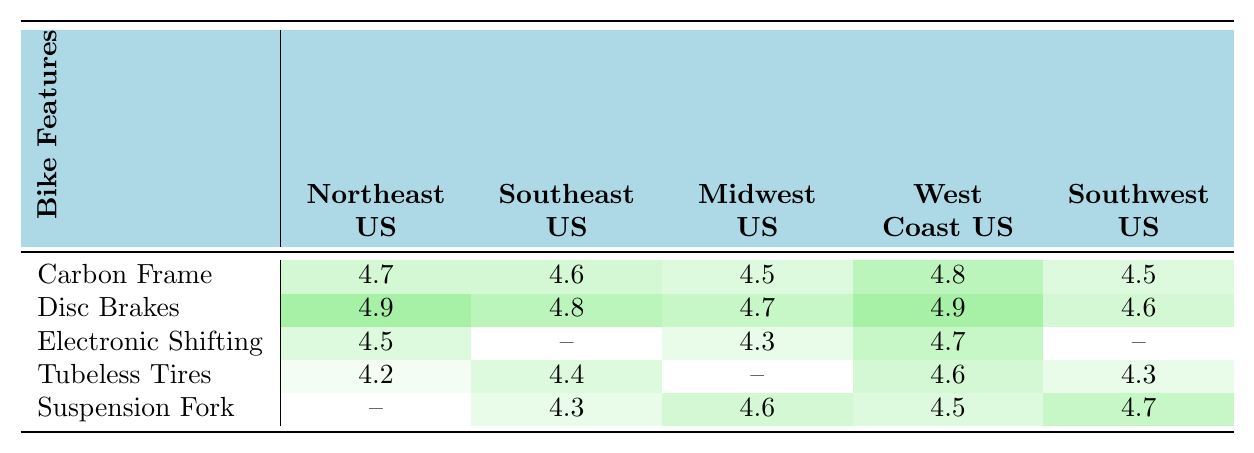What is the highest rating for Disc Brakes? Looking at the ratings for Disc Brakes across all regions, the highest rating is in the Northeast US and West Coast US, both with a score of 4.9.
Answer: 4.9 Which region has the lowest rating for Tubeless Tires? The Tubeless Tires rating in the Northeast US is the lowest at 4.2 when compared to other regions.
Answer: 4.2 Does the Midwest US have any ratings for Electronic Shifting? Yes, the Midwest US has a rating of 4.3 for Electronic Shifting, which can be found in the table.
Answer: Yes What is the average rating for Carbon Frame across all regions? The ratings for Carbon Frame are 4.7, 4.6, 4.5, 4.8, and 4.5. To find the average, we sum them (4.7 + 4.6 + 4.5 + 4.8 + 4.5 = 22.1) and then divide by 5, which gives us an average of 22.1 / 5 = 4.42.
Answer: 4.42 Which feature is rated highest in the Southeast US? The highest rated feature in the Southeast US is Disc Brakes at 4.8, based on the ratings in the table.
Answer: Disc Brakes Compare the ratings of Suspension Fork between Midwest US and Southwest US. Which one is higher? The Midwest US has a rating of 4.6 for Suspension Fork, while the Southwest US scored higher with a rating of 4.7.
Answer: Southwest US Is there a rating for Electronic Shifting in the Southeast US? No, there is no rating provided for Electronic Shifting in the Southeast US as it is represented with a dash (—) in the table.
Answer: No What is the difference between the highest and lowest ratings for the Carbon Frame feature? The highest rating for Carbon Frame is 4.8 (West Coast US) and the lowest is 4.5 (Midwest US and Southwest US). The difference is 4.8 - 4.5 = 0.3.
Answer: 0.3 How many features are rated for the Southwest US? The features rated for Southwest US are Carbon Frame, Disc Brakes, Tubeless Tires, and Suspension Fork (4 features total).
Answer: 4 If we consider all regions, which bike feature received the most ratings? Disc Brakes received ratings from all regions, making it the most rated feature at 4.9, 4.8, 4.7, 4.9, and 4.6.
Answer: Disc Brakes 